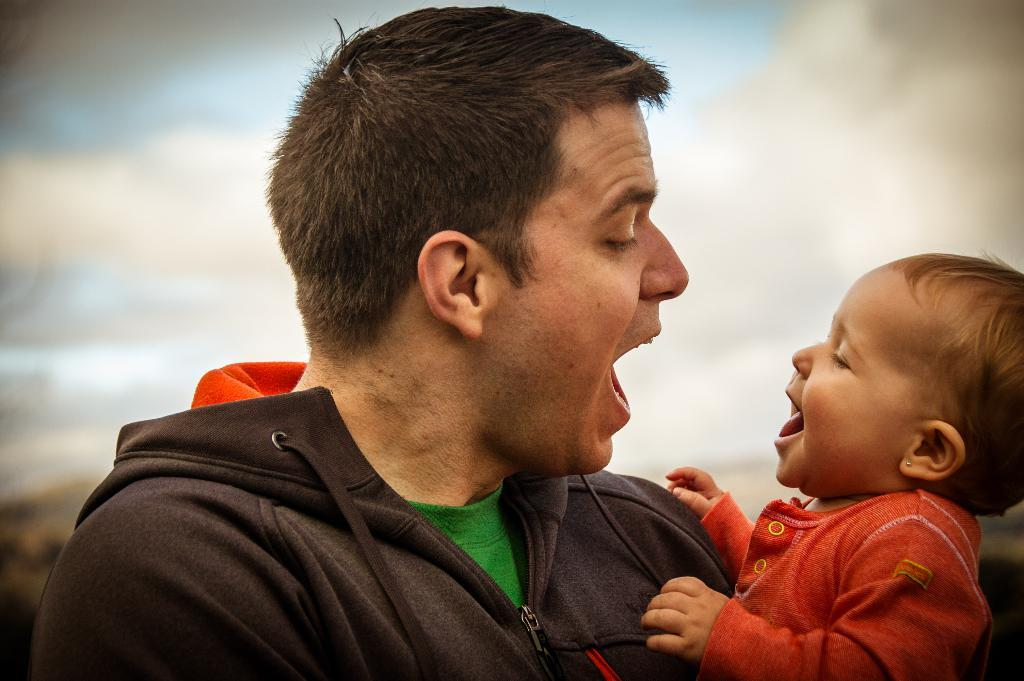Who is the main subject in the image? There is a man in the image. What is the man doing in the image? The man is carrying a baby. Can you describe the background of the image? The background of the image is blurred. What type of zebra can be seen in the background of the image? There is no zebra present in the image; the background is blurred. How many stamps are visible on the baby's forehead in the image? There are no stamps visible on the baby's forehead in the image. 